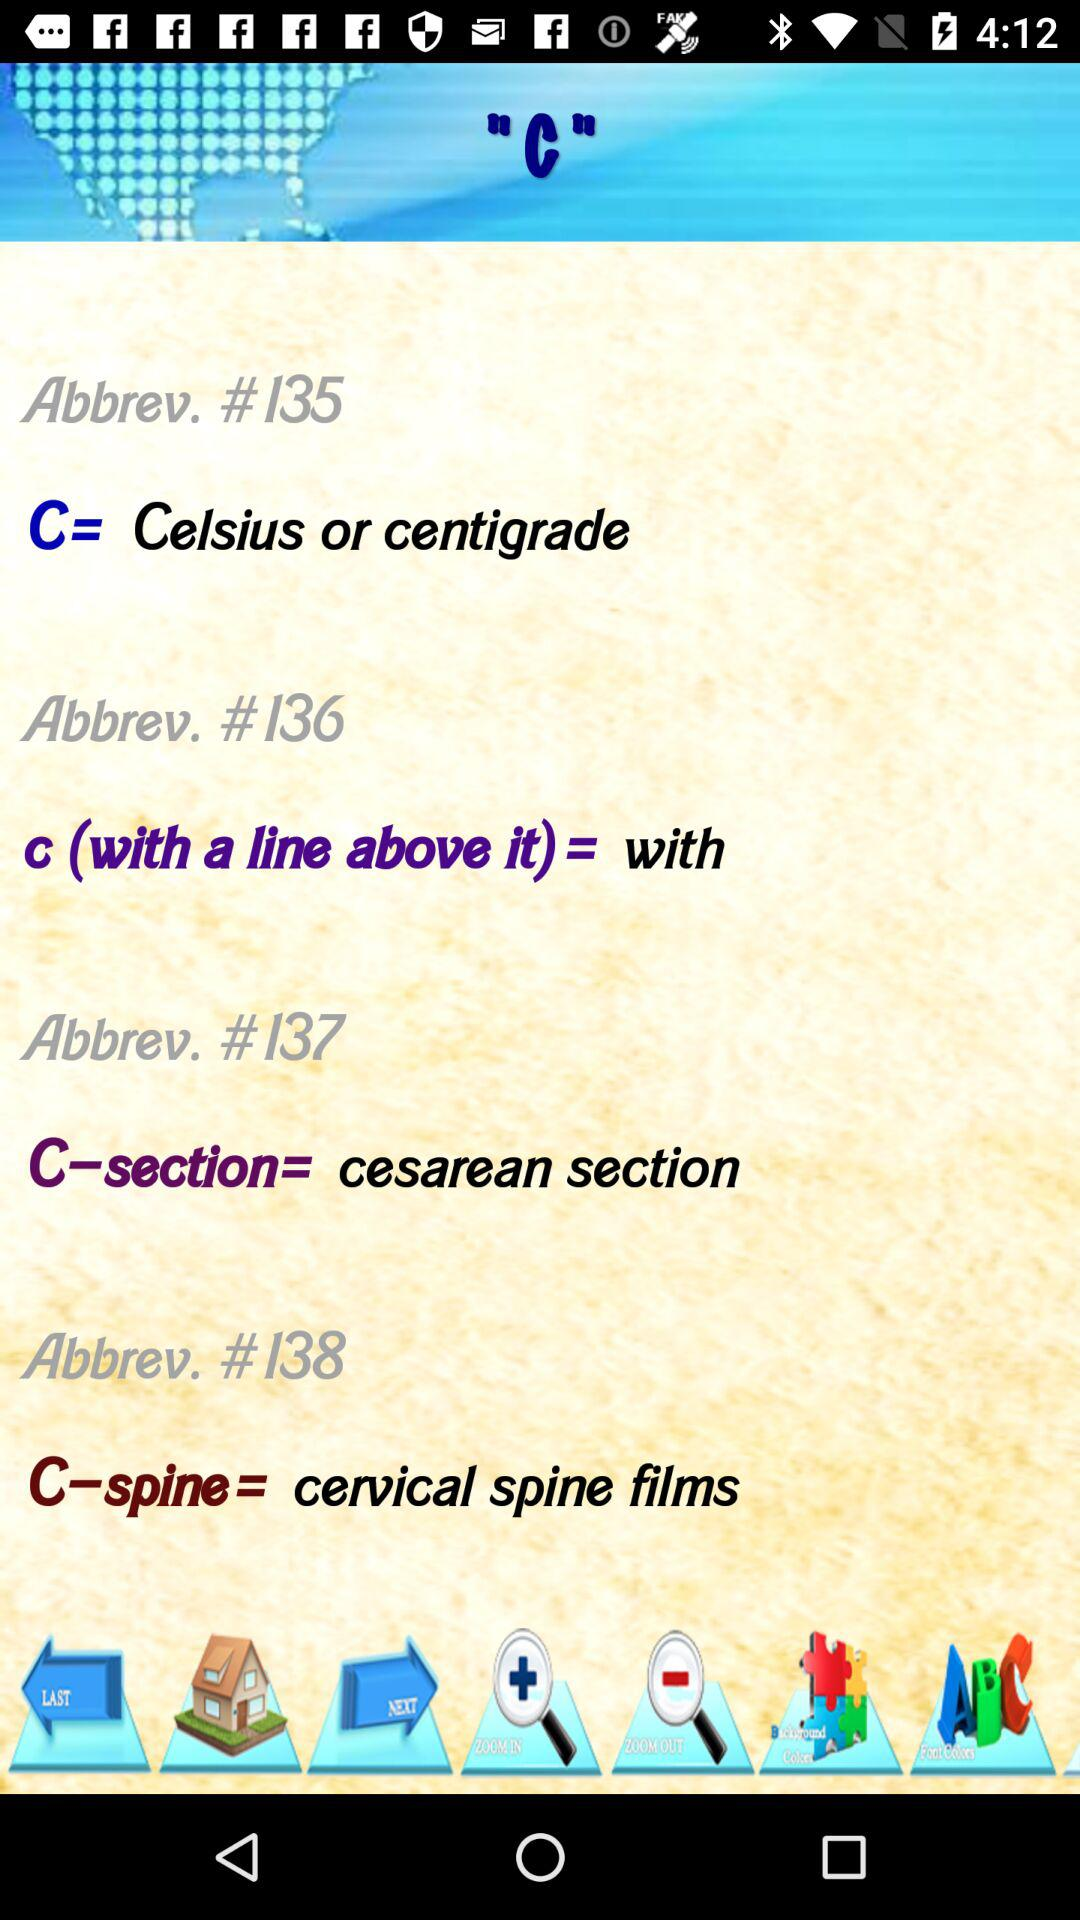What is mentioned in "Abbrev. #135"? In "Abbrev. #135", "C= Celsius or centigrade" is mentioned. 